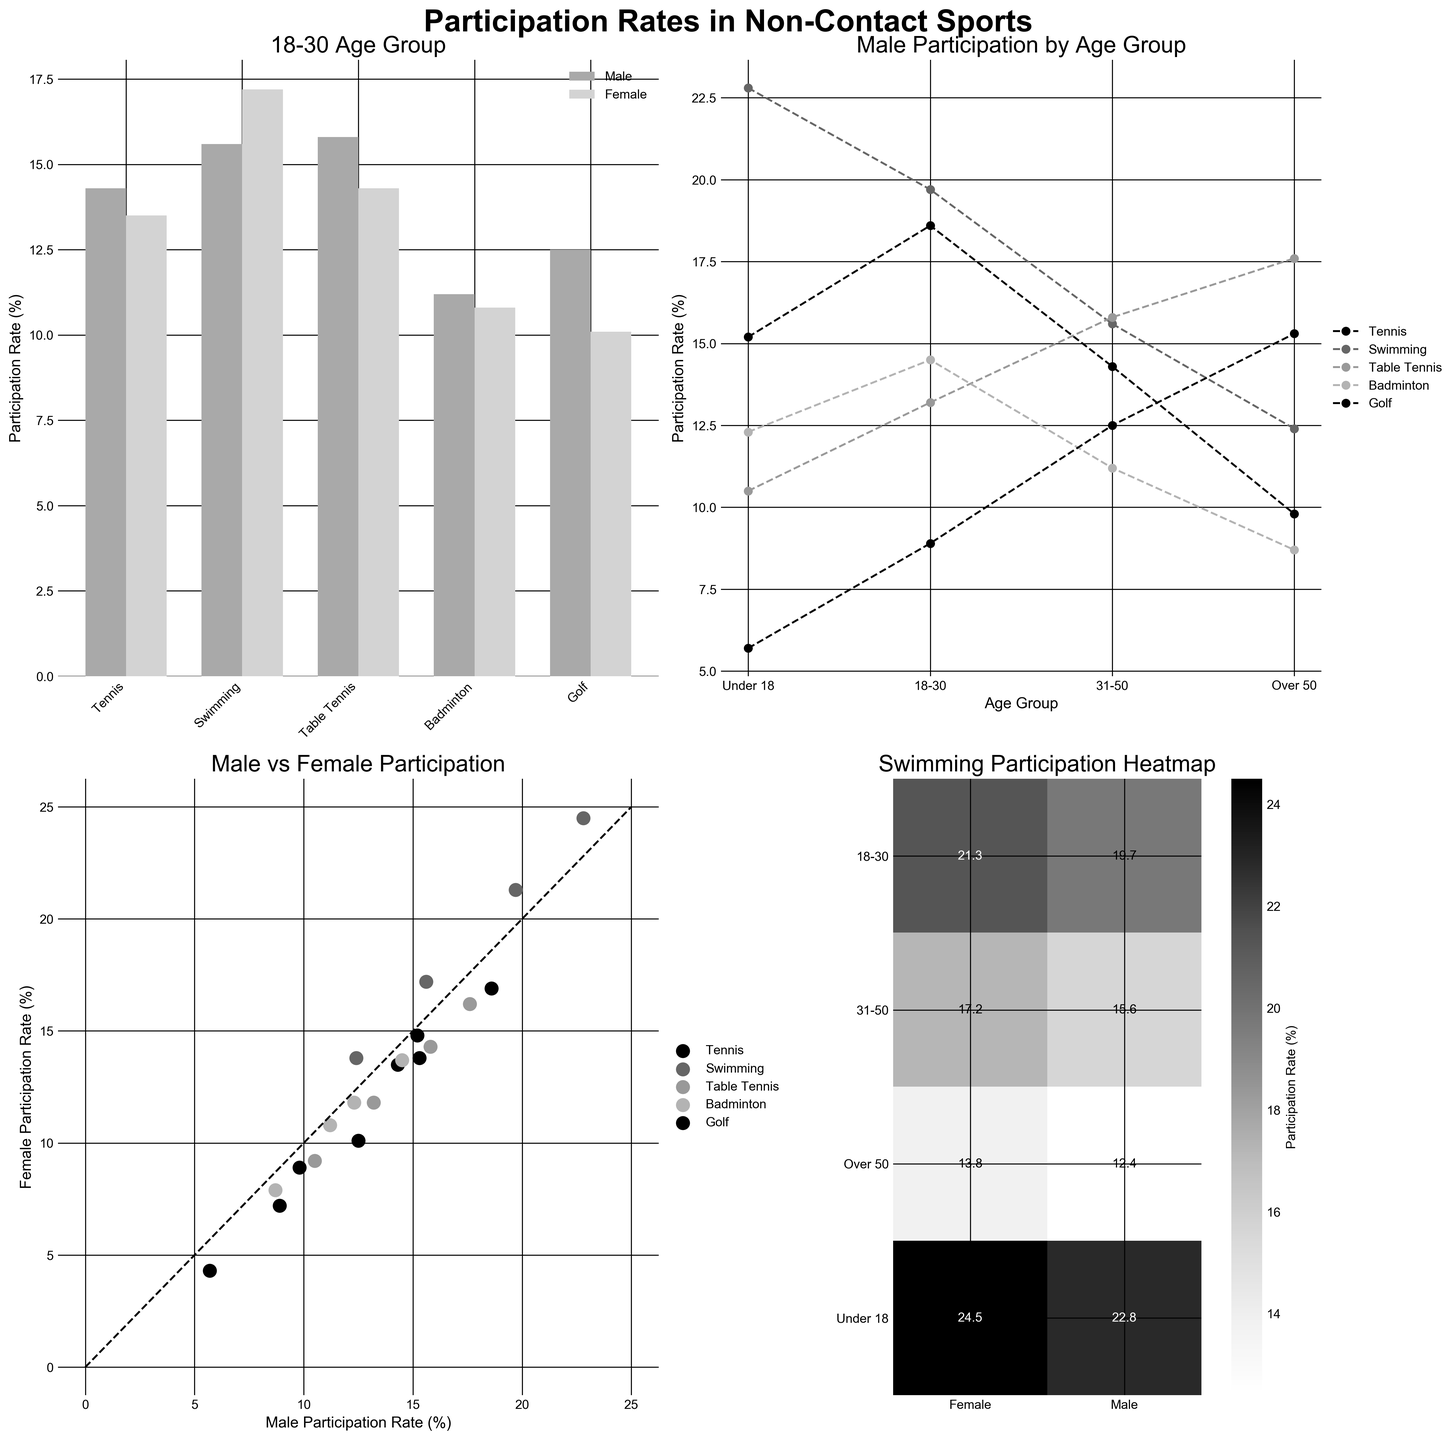What is the title of the figure? The title of the figure is displayed at the top. It reads 'Participation Rates in Non-Contact Sports'.
Answer: Participation Rates in Non-Contact Sports What are the sports listed in the bar plot for the 18-30 age group? In the bar plot, the sports listed are the categories along the x-axis. They include Tennis, Swimming, Table Tennis, Badminton, and Golf.
Answer: Tennis, Swimming, Table Tennis, Badminton, Golf Which gender has a higher participation rate in Swimming in the 18-30 age group? The bar plot comparing male and female participation rates in the 18-30 age group shows that the bar for female participation in Swimming is higher than that for males.
Answer: Female What is the participation rate of Tennis for females over 50? The line plot showing male participation by age group provides no direct information about females. For female sports rates, refer to the scatter plot or the legend in any subplot. The data shows a 9.8% rate.
Answer: 8.9% Which age group has the highest participation rate in Golf for males? The line graph showing male participation by age group has various sports plotted, including Golf. The highest point for Golf on this line graph is for the age group Over 50.
Answer: Over 50 Compare the participation rates of males and females in Table Tennis for the 31-50 age group. Who has a higher rate? The participation rates from the bar plot for the 31-50 age group can be compared between males and females. Table Tennis rates are shown as bars, and males (15.8%) have a slightly higher rate than females (14.3%).
Answer: Males What is the pattern of Swimming participation rates across the age groups for females? On the heatmap, rates of Swimming for females across age groups can be identified by reading the values: Under 18 (24.5%), 18-30 (21.3%), 31-50 (17.2%), and Over 50 (13.8%). The pattern shows a decreasing trend with each older age group.
Answer: Decreasing Are there any sports where male and female participation rates are nearly equal? The scatter plot compares male and female participation rates. Look for points near the diagonal line. For example, the data point for Table Tennis shows nearly equal rates for males and females.
Answer: Table Tennis Which sport shows the largest difference in participation rates between genders in the 18-30 age group? In the bar plot for the 18-30 age group, compare the height of the bars for each sport. Swimming shows the largest difference with females (21.3%) having higher participation rates than males (19.7%).
Answer: Swimming What is the overall trend of Tennis participation across all age groups for both genders? The line plot for Male Participation by Age Group and scatter demonstrates Tennis rates, showing a general declining trend as age increases. The heatmap showing female rates reflects the same pattern across ages.
Answer: Declining 